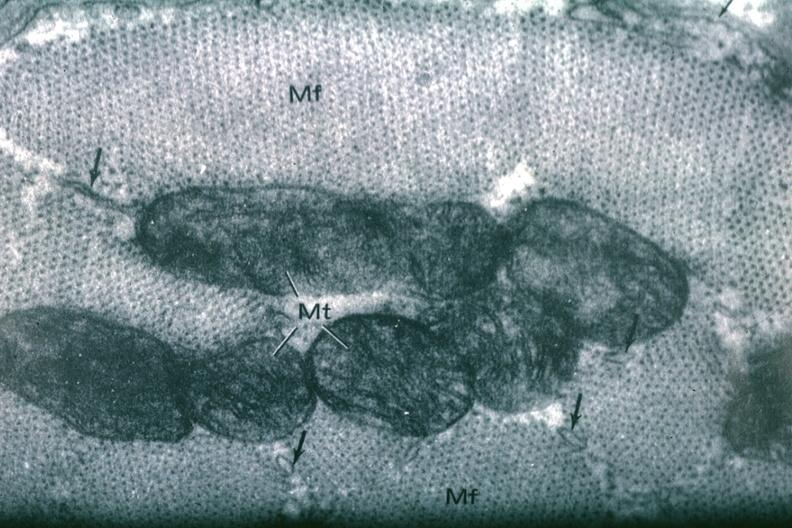does this image show cross section myofibril?
Answer the question using a single word or phrase. Yes 